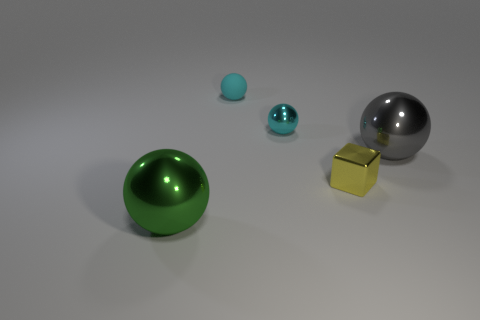What is the material of the green thing that is the same shape as the cyan matte thing?
Offer a very short reply. Metal. Is there any other thing that is the same size as the block?
Ensure brevity in your answer.  Yes. How big is the shiny ball that is behind the big shiny object behind the green ball?
Give a very brief answer. Small. What is the color of the metallic block?
Your response must be concise. Yellow. There is a cyan sphere that is behind the tiny cyan metal ball; how many small matte objects are in front of it?
Make the answer very short. 0. There is a large metallic ball that is left of the large gray object; are there any green shiny things that are behind it?
Provide a succinct answer. No. There is a small metallic cube; are there any metallic balls right of it?
Your answer should be very brief. Yes. Do the green object in front of the tiny yellow shiny block and the rubber object have the same shape?
Make the answer very short. Yes. How many large gray shiny things are the same shape as the cyan shiny thing?
Your answer should be compact. 1. Is there a tiny brown cube that has the same material as the yellow cube?
Provide a short and direct response. No. 